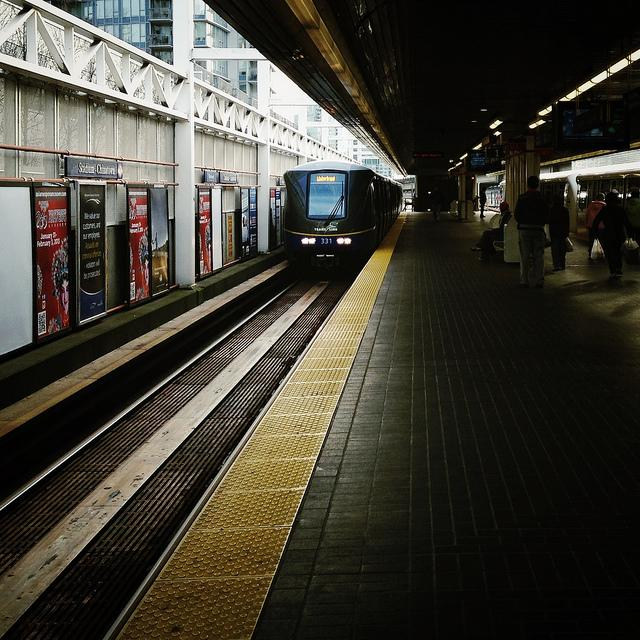What are the colorful posters on the wall used for? advertising 